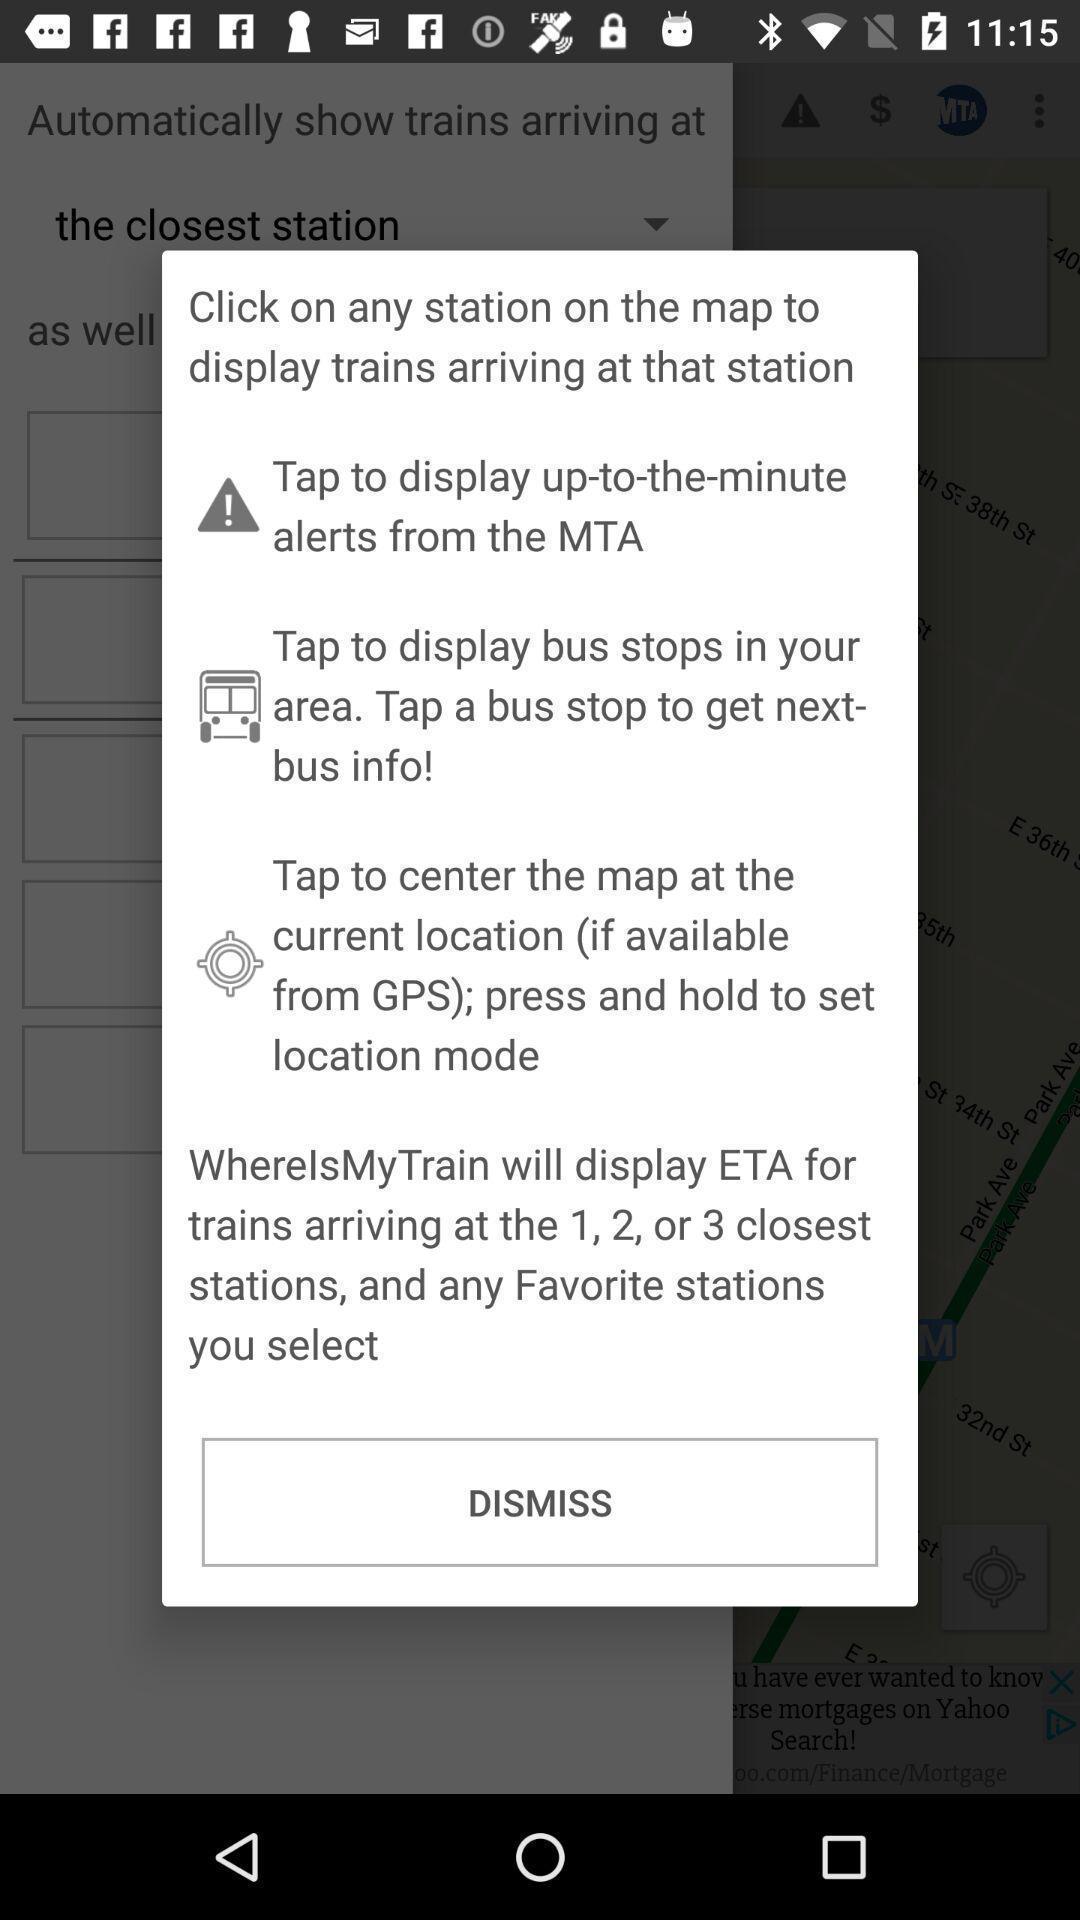Please provide a description for this image. Pop-up shows train details with dismiss option. 